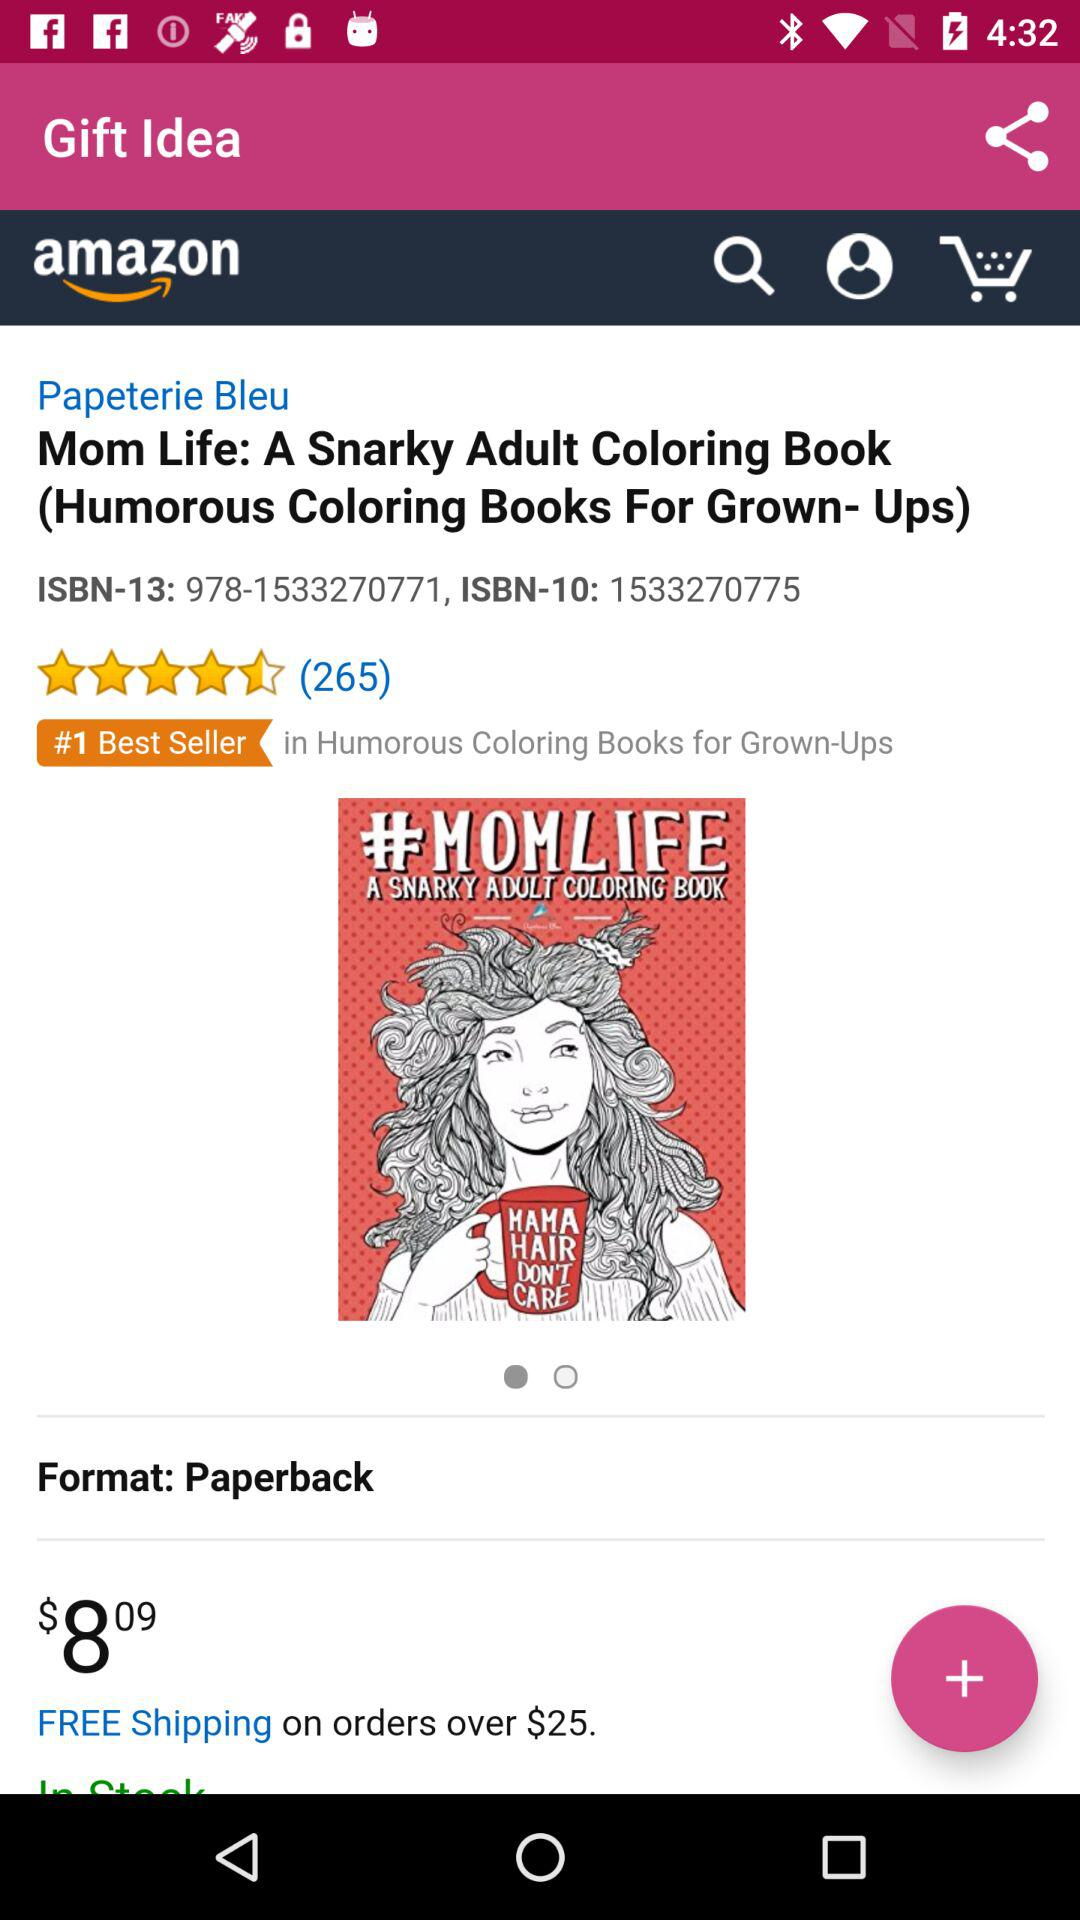What is the book name? The book name is "Mom Life: A Snarky Adult Coloring Book". 